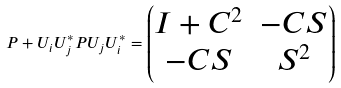Convert formula to latex. <formula><loc_0><loc_0><loc_500><loc_500>P + U _ { i } U _ { j } ^ { * } P U _ { j } U _ { i } ^ { * } = \begin{pmatrix} I + C ^ { 2 } & - C S \\ - C S & S ^ { 2 } \end{pmatrix}</formula> 